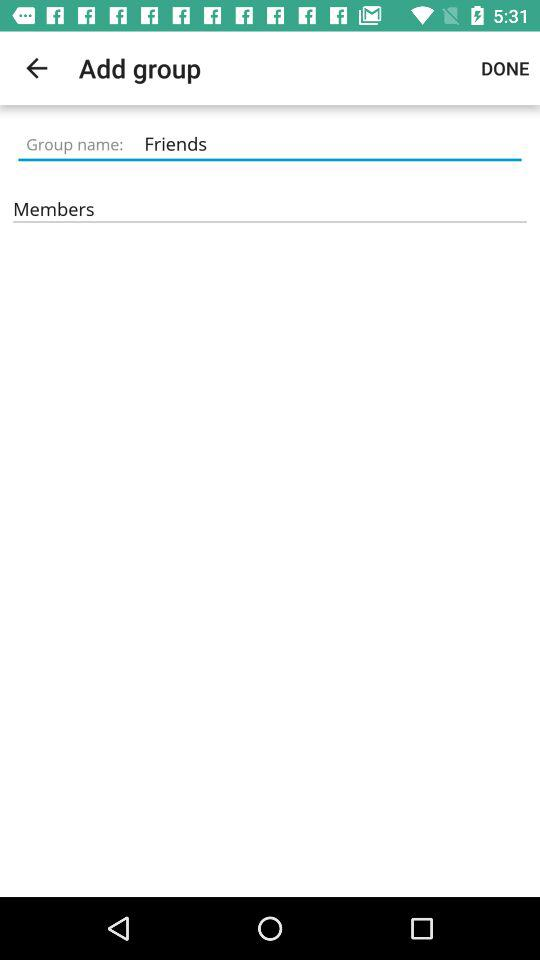Which friends have been added to the group?
When the provided information is insufficient, respond with <no answer>. <no answer> 